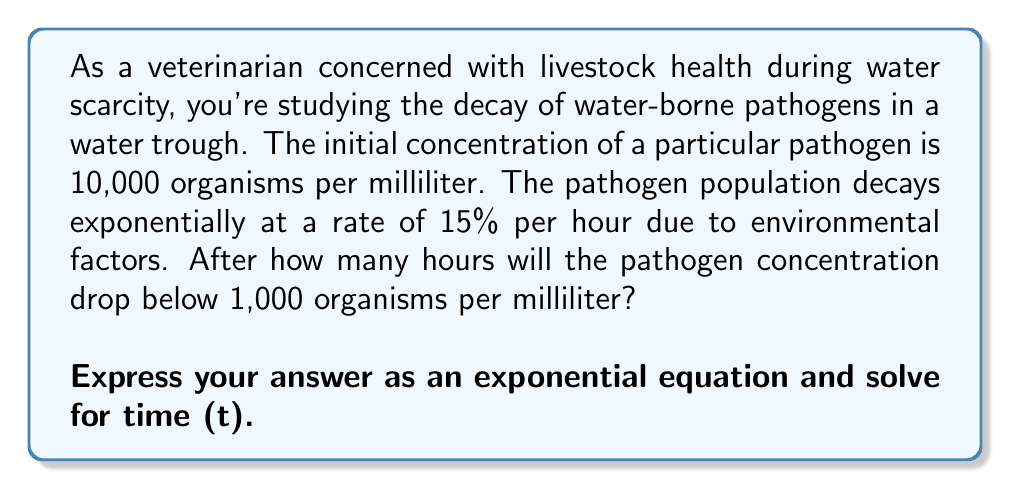Provide a solution to this math problem. Let's approach this step-by-step:

1) The exponential decay formula is:
   $$A(t) = A_0 \cdot (1-r)^t$$
   where $A(t)$ is the amount at time t, $A_0$ is the initial amount, r is the decay rate, and t is time.

2) We know:
   $A_0 = 10,000$ (initial concentration)
   $r = 0.15$ (15% decay rate)
   We want to find t when $A(t) < 1,000$

3) Let's set up the equation:
   $$1,000 = 10,000 \cdot (1-0.15)^t$$

4) Simplify:
   $$1,000 = 10,000 \cdot (0.85)^t$$

5) Divide both sides by 10,000:
   $$0.1 = (0.85)^t$$

6) Take the natural log of both sides:
   $$\ln(0.1) = \ln((0.85)^t)$$

7) Use the logarithm property $\ln(a^b) = b\ln(a)$:
   $$\ln(0.1) = t \cdot \ln(0.85)$$

8) Solve for t:
   $$t = \frac{\ln(0.1)}{\ln(0.85)} \approx 14.96$$

Therefore, it will take approximately 14.96 hours for the pathogen concentration to drop below 1,000 organisms per milliliter.
Answer: $t = \frac{\ln(0.1)}{\ln(0.85)} \approx 14.96$ hours 